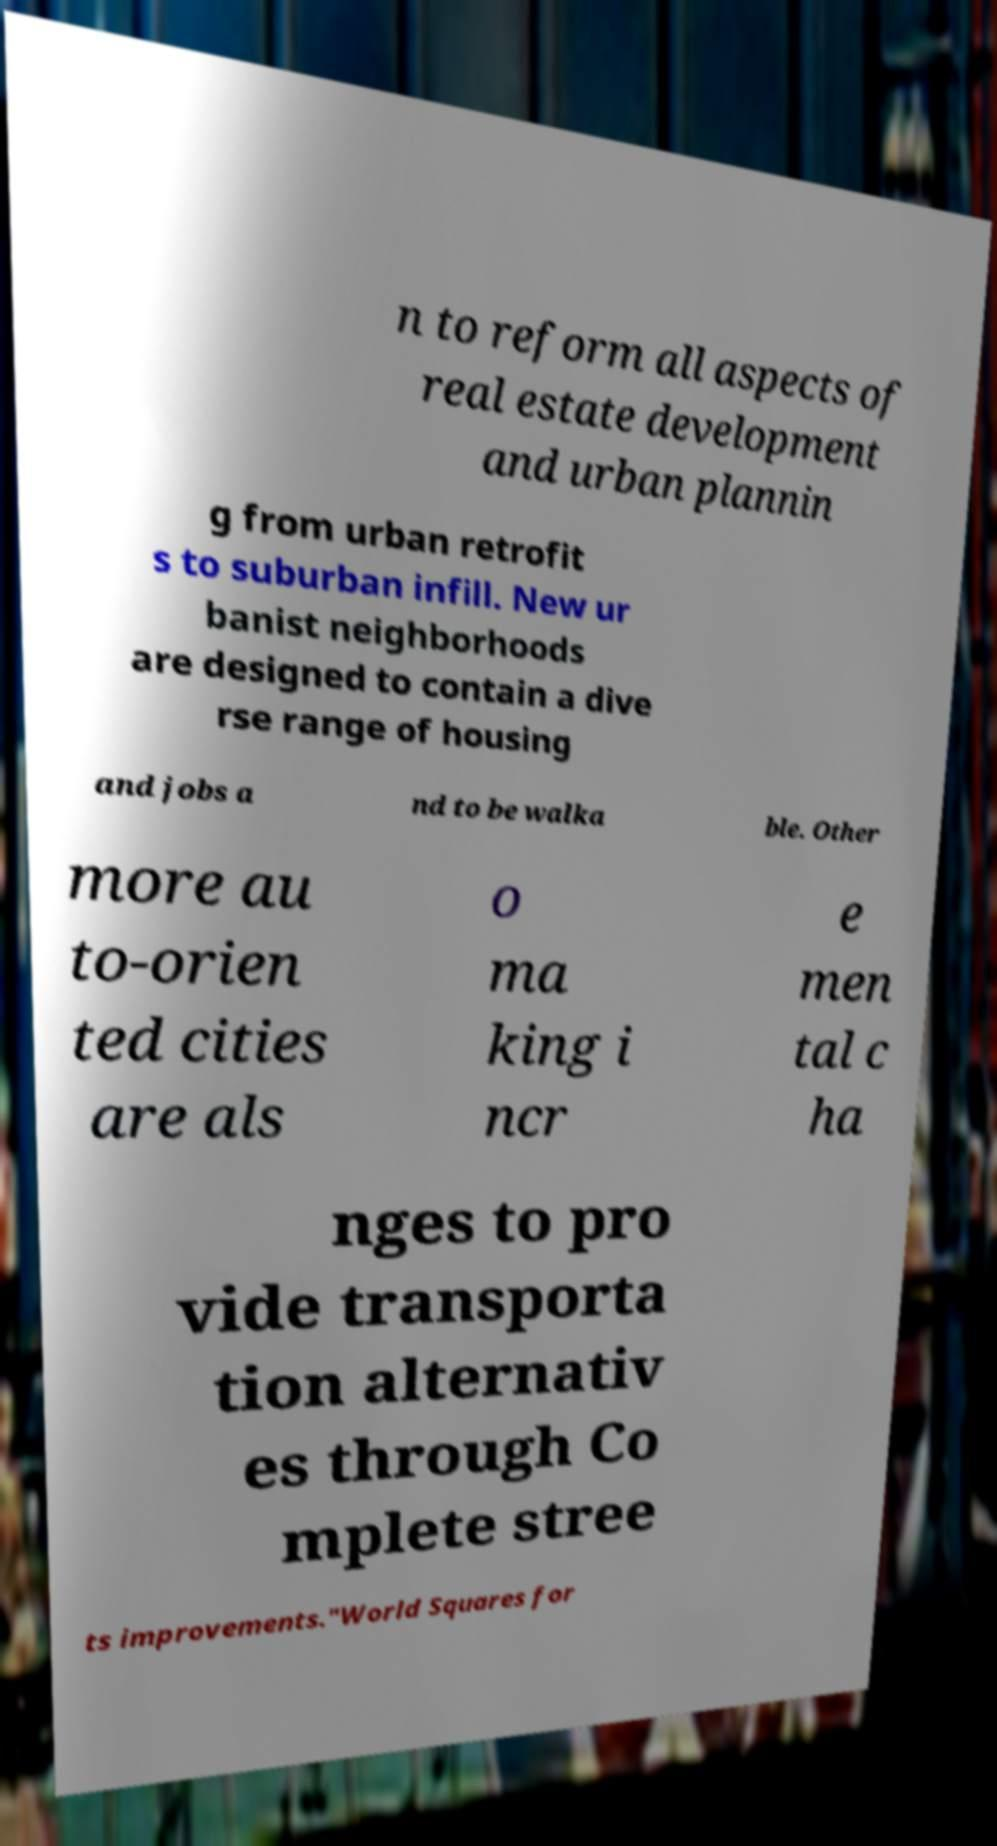Can you accurately transcribe the text from the provided image for me? n to reform all aspects of real estate development and urban plannin g from urban retrofit s to suburban infill. New ur banist neighborhoods are designed to contain a dive rse range of housing and jobs a nd to be walka ble. Other more au to-orien ted cities are als o ma king i ncr e men tal c ha nges to pro vide transporta tion alternativ es through Co mplete stree ts improvements."World Squares for 